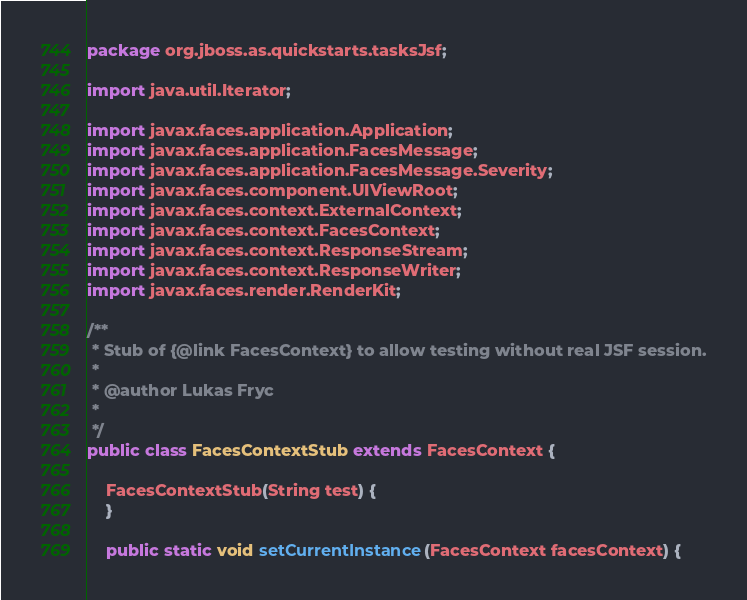<code> <loc_0><loc_0><loc_500><loc_500><_Java_>package org.jboss.as.quickstarts.tasksJsf;

import java.util.Iterator;

import javax.faces.application.Application;
import javax.faces.application.FacesMessage;
import javax.faces.application.FacesMessage.Severity;
import javax.faces.component.UIViewRoot;
import javax.faces.context.ExternalContext;
import javax.faces.context.FacesContext;
import javax.faces.context.ResponseStream;
import javax.faces.context.ResponseWriter;
import javax.faces.render.RenderKit;

/**
 * Stub of {@link FacesContext} to allow testing without real JSF session.
 * 
 * @author Lukas Fryc
 * 
 */
public class FacesContextStub extends FacesContext {

    FacesContextStub(String test) {
    }

    public static void setCurrentInstance(FacesContext facesContext) {</code> 